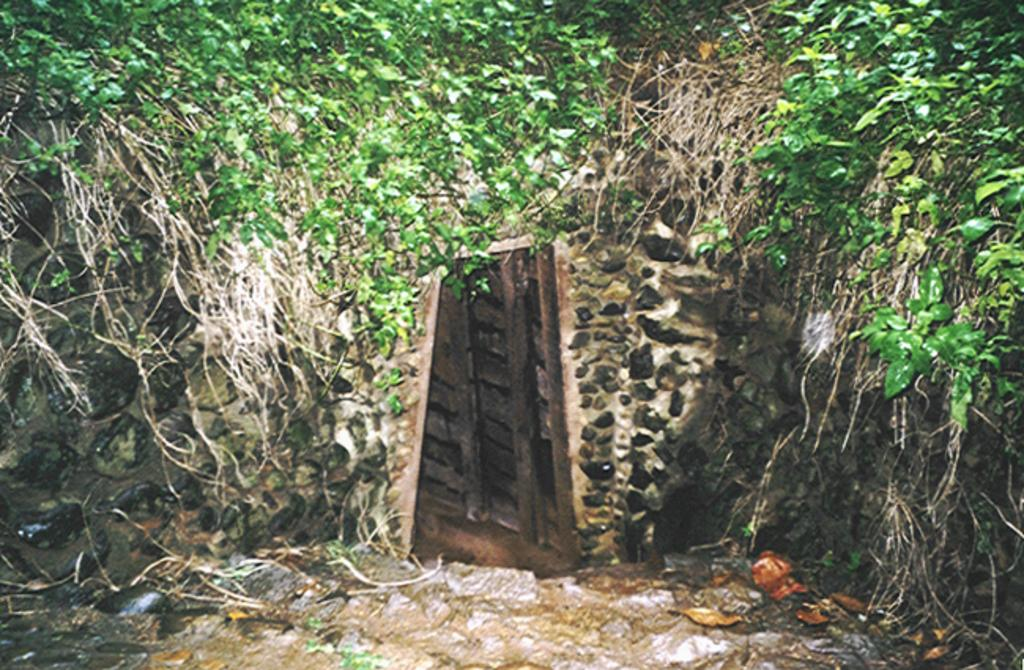What type of structure is visible in the image? There is a stone wall in the image. Does the stone wall have any openings? Yes, the stone wall has a door. What type of vegetation is growing on the stone wall? There are creeper plants on the stone wall. What type of tree can be seen blowing in the wind in the image? There is no tree present in the image, and therefore no tree can be seen blowing in the wind. 